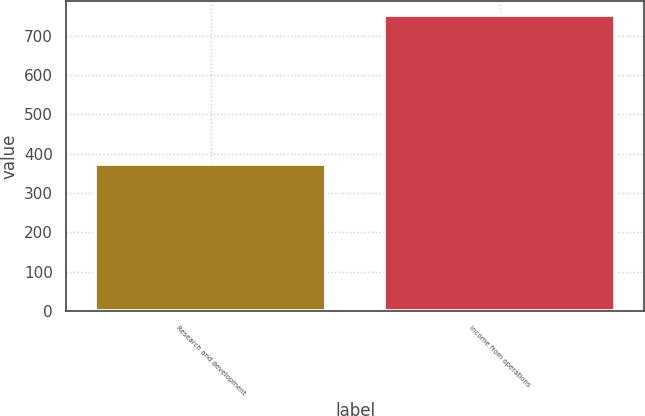Convert chart. <chart><loc_0><loc_0><loc_500><loc_500><bar_chart><fcel>Research and development<fcel>Income from operations<nl><fcel>375<fcel>751<nl></chart> 